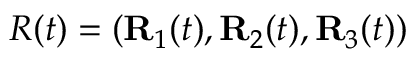<formula> <loc_0><loc_0><loc_500><loc_500>R ( t ) = ( { R } _ { 1 } ( t ) , { R } _ { 2 } ( t ) , { R } _ { 3 } ( t ) )</formula> 